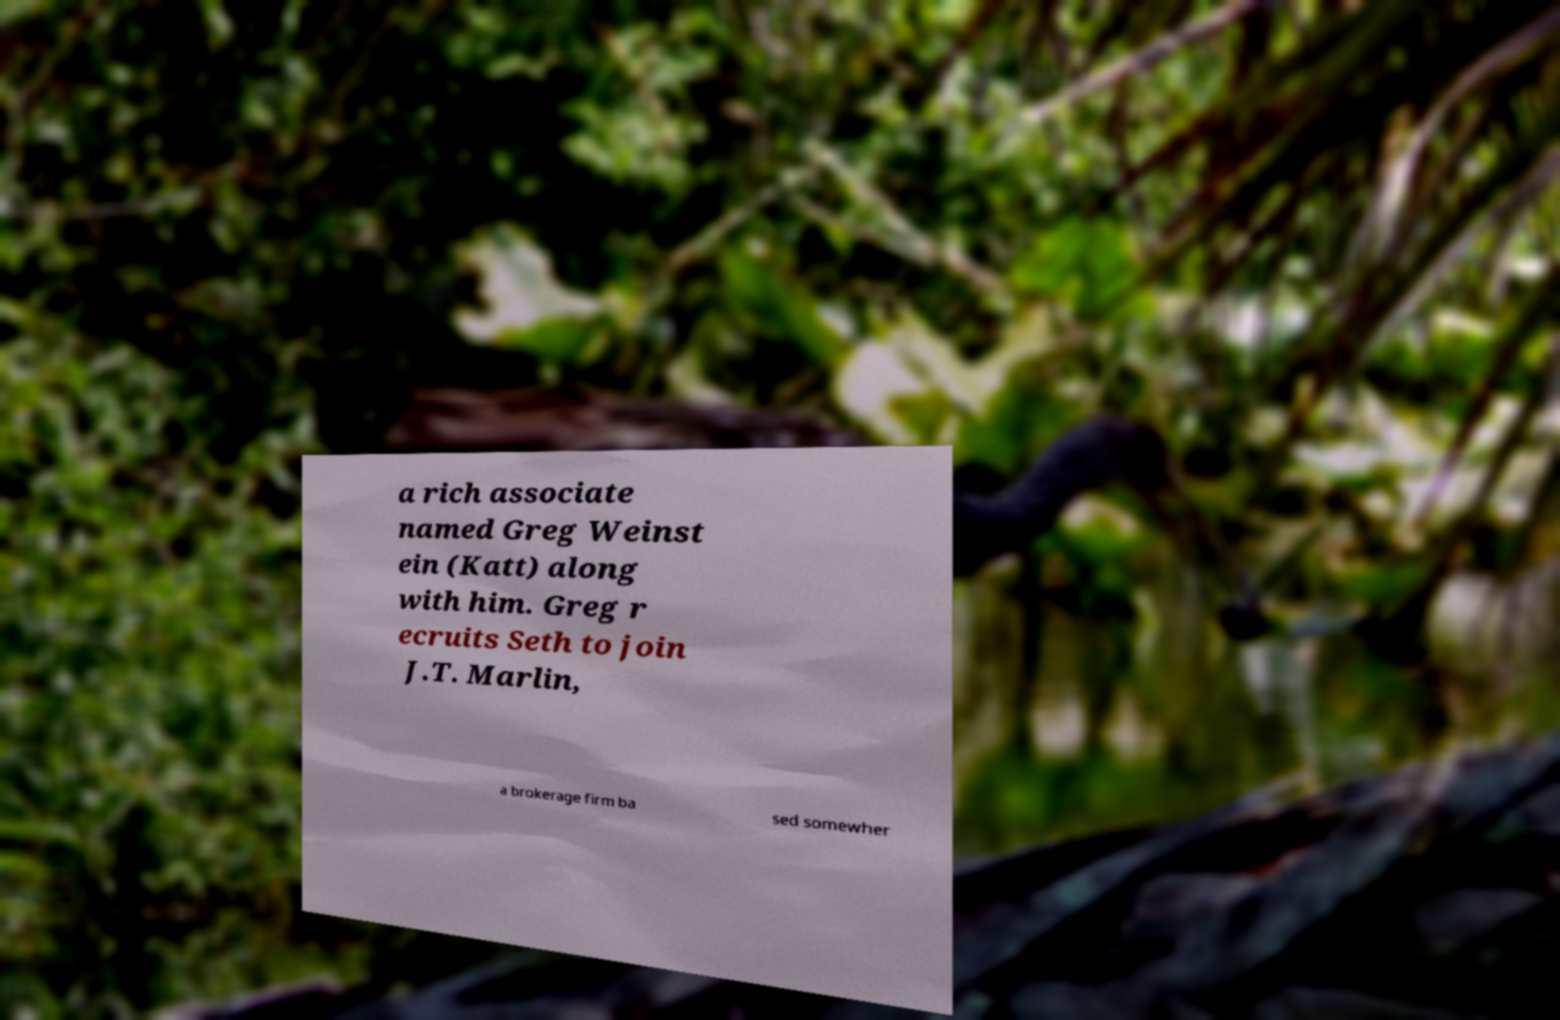What messages or text are displayed in this image? I need them in a readable, typed format. a rich associate named Greg Weinst ein (Katt) along with him. Greg r ecruits Seth to join J.T. Marlin, a brokerage firm ba sed somewher 